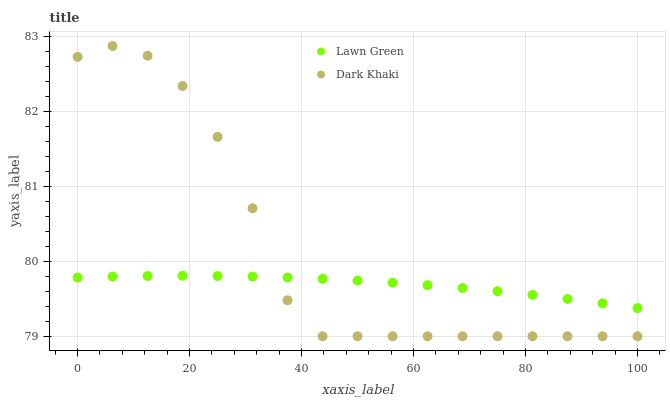Does Lawn Green have the minimum area under the curve?
Answer yes or no. Yes. Does Dark Khaki have the maximum area under the curve?
Answer yes or no. Yes. Does Lawn Green have the maximum area under the curve?
Answer yes or no. No. Is Lawn Green the smoothest?
Answer yes or no. Yes. Is Dark Khaki the roughest?
Answer yes or no. Yes. Is Lawn Green the roughest?
Answer yes or no. No. Does Dark Khaki have the lowest value?
Answer yes or no. Yes. Does Lawn Green have the lowest value?
Answer yes or no. No. Does Dark Khaki have the highest value?
Answer yes or no. Yes. Does Lawn Green have the highest value?
Answer yes or no. No. Does Lawn Green intersect Dark Khaki?
Answer yes or no. Yes. Is Lawn Green less than Dark Khaki?
Answer yes or no. No. Is Lawn Green greater than Dark Khaki?
Answer yes or no. No. 